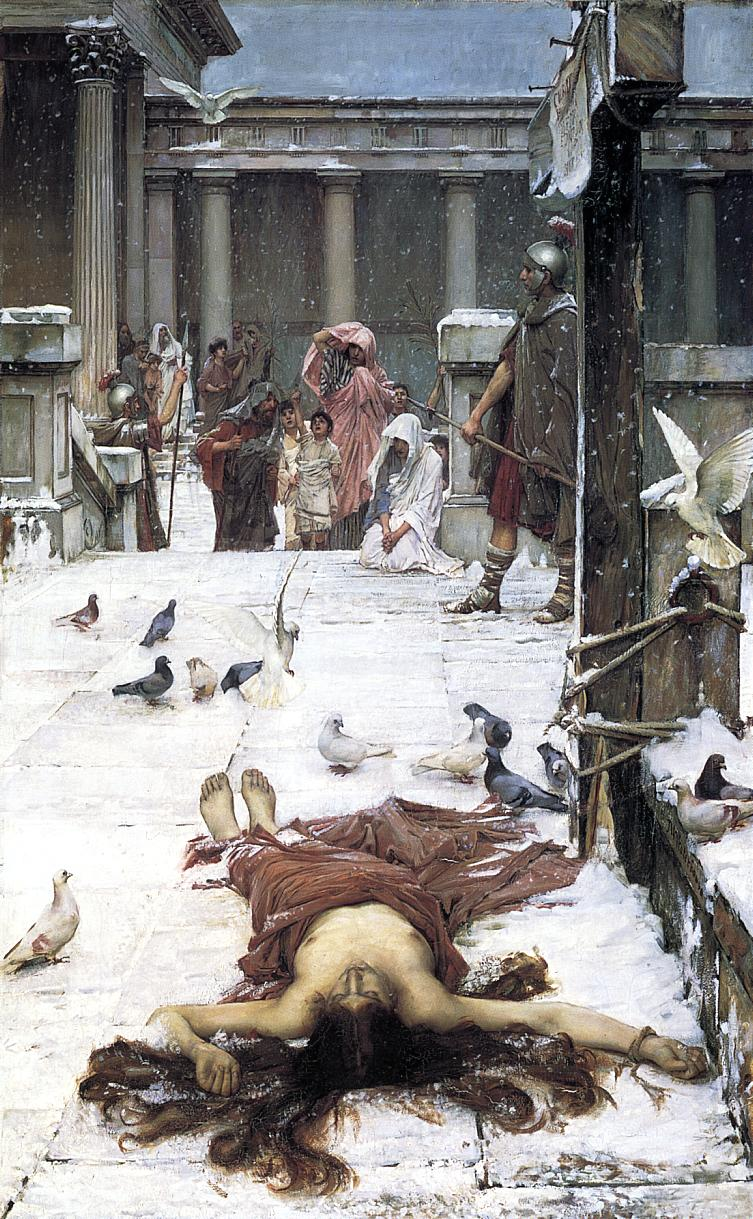What might the presence of pigeons imply in this historical context? Pigeons in this scene could symbolize several things. Historically, pigeons are often seen as symbols of peace or the human spirit, which might contrast the scene's apparent tragedy and tension. In urban settings, pigeons also represent the commonplace or everyday life, grounding the scene in a relatable reality despite the dramatic event. Their vigorous activity around the solemn and static humans emphasizes life moving forward, oblivious to individual suffering. 